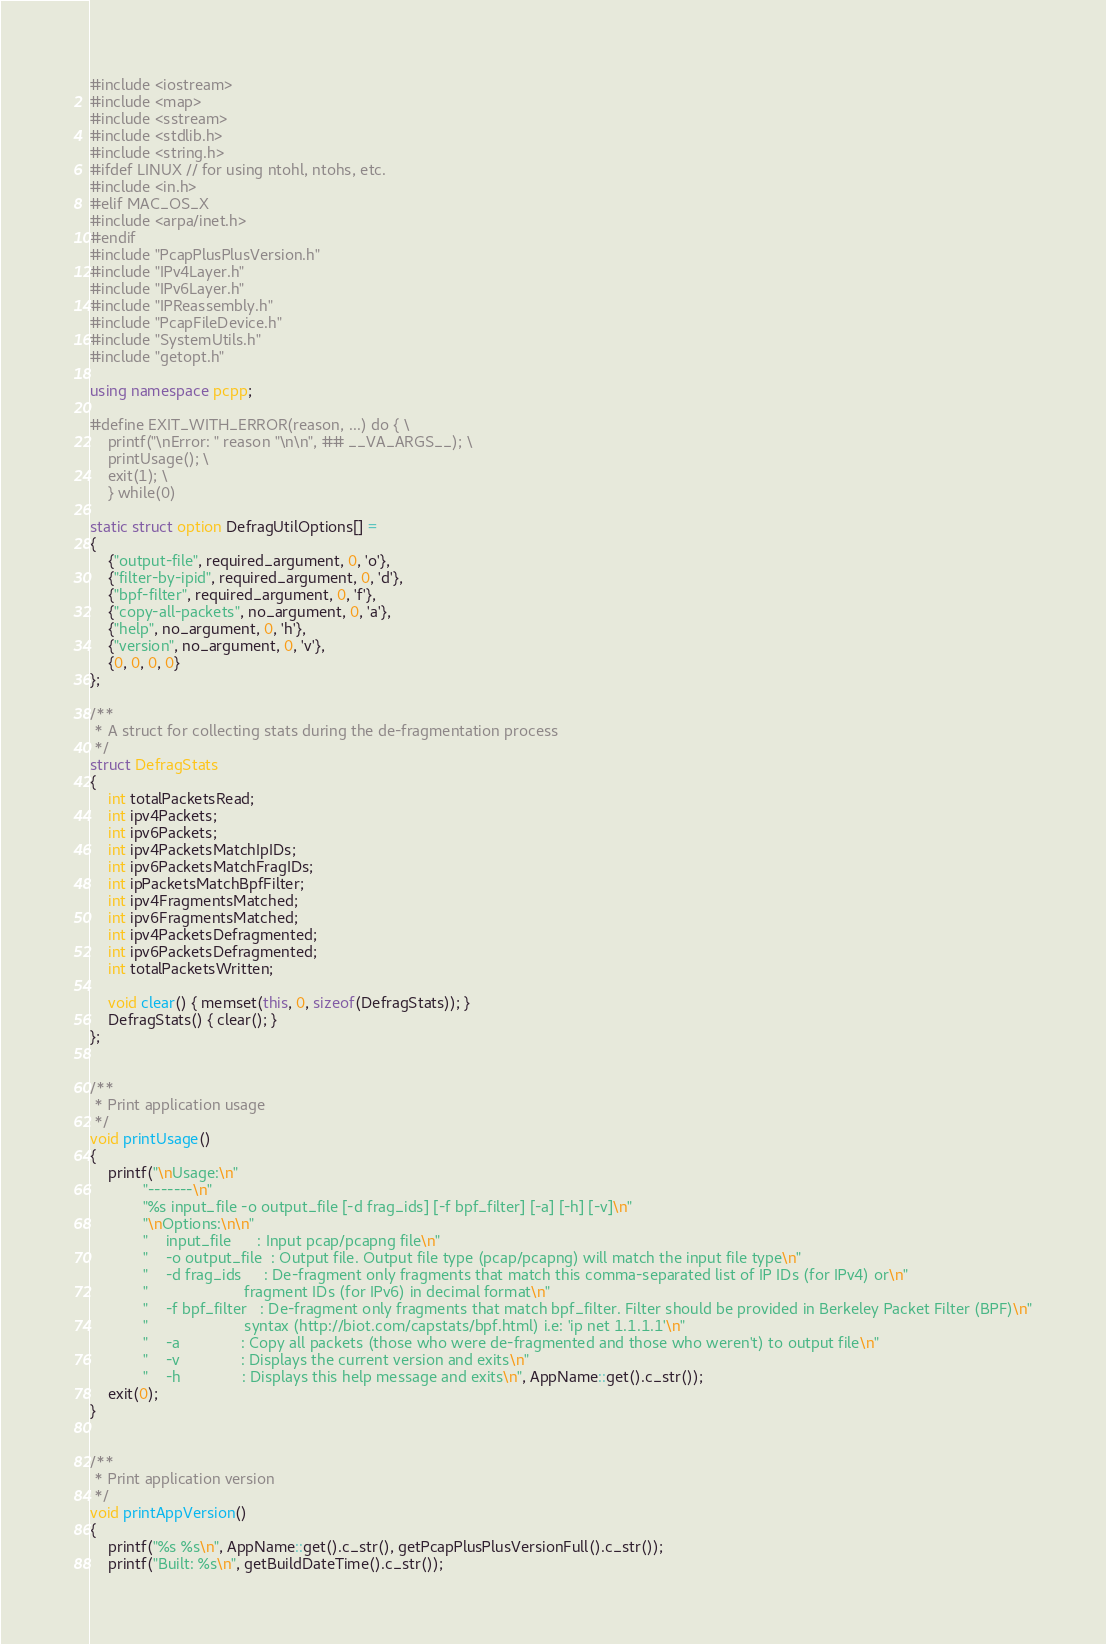Convert code to text. <code><loc_0><loc_0><loc_500><loc_500><_C++_>#include <iostream>
#include <map>
#include <sstream>
#include <stdlib.h>
#include <string.h>
#ifdef LINUX // for using ntohl, ntohs, etc.
#include <in.h>
#elif MAC_OS_X
#include <arpa/inet.h>
#endif
#include "PcapPlusPlusVersion.h"
#include "IPv4Layer.h"
#include "IPv6Layer.h"
#include "IPReassembly.h"
#include "PcapFileDevice.h"
#include "SystemUtils.h"
#include "getopt.h"

using namespace pcpp;

#define EXIT_WITH_ERROR(reason, ...) do { \
	printf("\nError: " reason "\n\n", ## __VA_ARGS__); \
	printUsage(); \
	exit(1); \
	} while(0)

static struct option DefragUtilOptions[] =
{
	{"output-file", required_argument, 0, 'o'},
	{"filter-by-ipid", required_argument, 0, 'd'},
	{"bpf-filter", required_argument, 0, 'f'},
	{"copy-all-packets", no_argument, 0, 'a'},
	{"help", no_argument, 0, 'h'},
	{"version", no_argument, 0, 'v'},
    {0, 0, 0, 0}
};

/**
 * A struct for collecting stats during the de-fragmentation process
 */
struct DefragStats
{
	int totalPacketsRead;
	int ipv4Packets;
	int ipv6Packets;
	int ipv4PacketsMatchIpIDs;
	int ipv6PacketsMatchFragIDs;
	int ipPacketsMatchBpfFilter;
	int ipv4FragmentsMatched;
	int ipv6FragmentsMatched;
	int ipv4PacketsDefragmented;
	int ipv6PacketsDefragmented;
	int totalPacketsWritten;

	void clear() { memset(this, 0, sizeof(DefragStats)); }
	DefragStats() { clear(); }
};


/**
 * Print application usage
 */
void printUsage()
{
	printf("\nUsage:\n"
			"-------\n"
			"%s input_file -o output_file [-d frag_ids] [-f bpf_filter] [-a] [-h] [-v]\n"
			"\nOptions:\n\n"
			"    input_file      : Input pcap/pcapng file\n"
			"    -o output_file  : Output file. Output file type (pcap/pcapng) will match the input file type\n"
			"    -d frag_ids     : De-fragment only fragments that match this comma-separated list of IP IDs (for IPv4) or\n"
			"                      fragment IDs (for IPv6) in decimal format\n"
			"    -f bpf_filter   : De-fragment only fragments that match bpf_filter. Filter should be provided in Berkeley Packet Filter (BPF)\n"
			"                      syntax (http://biot.com/capstats/bpf.html) i.e: 'ip net 1.1.1.1'\n"
			"    -a              : Copy all packets (those who were de-fragmented and those who weren't) to output file\n"
			"    -v              : Displays the current version and exits\n"
			"    -h              : Displays this help message and exits\n", AppName::get().c_str());
	exit(0);
}


/**
 * Print application version
 */
void printAppVersion()
{
	printf("%s %s\n", AppName::get().c_str(), getPcapPlusPlusVersionFull().c_str());
	printf("Built: %s\n", getBuildDateTime().c_str());</code> 